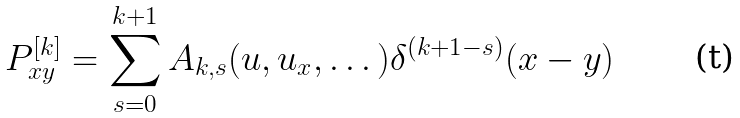<formula> <loc_0><loc_0><loc_500><loc_500>P _ { x y } ^ { [ k ] } = \sum _ { s = 0 } ^ { k + 1 } A _ { k , s } ( u , u _ { x } , \dots ) \delta ^ { ( k + 1 - s ) } ( x - y )</formula> 